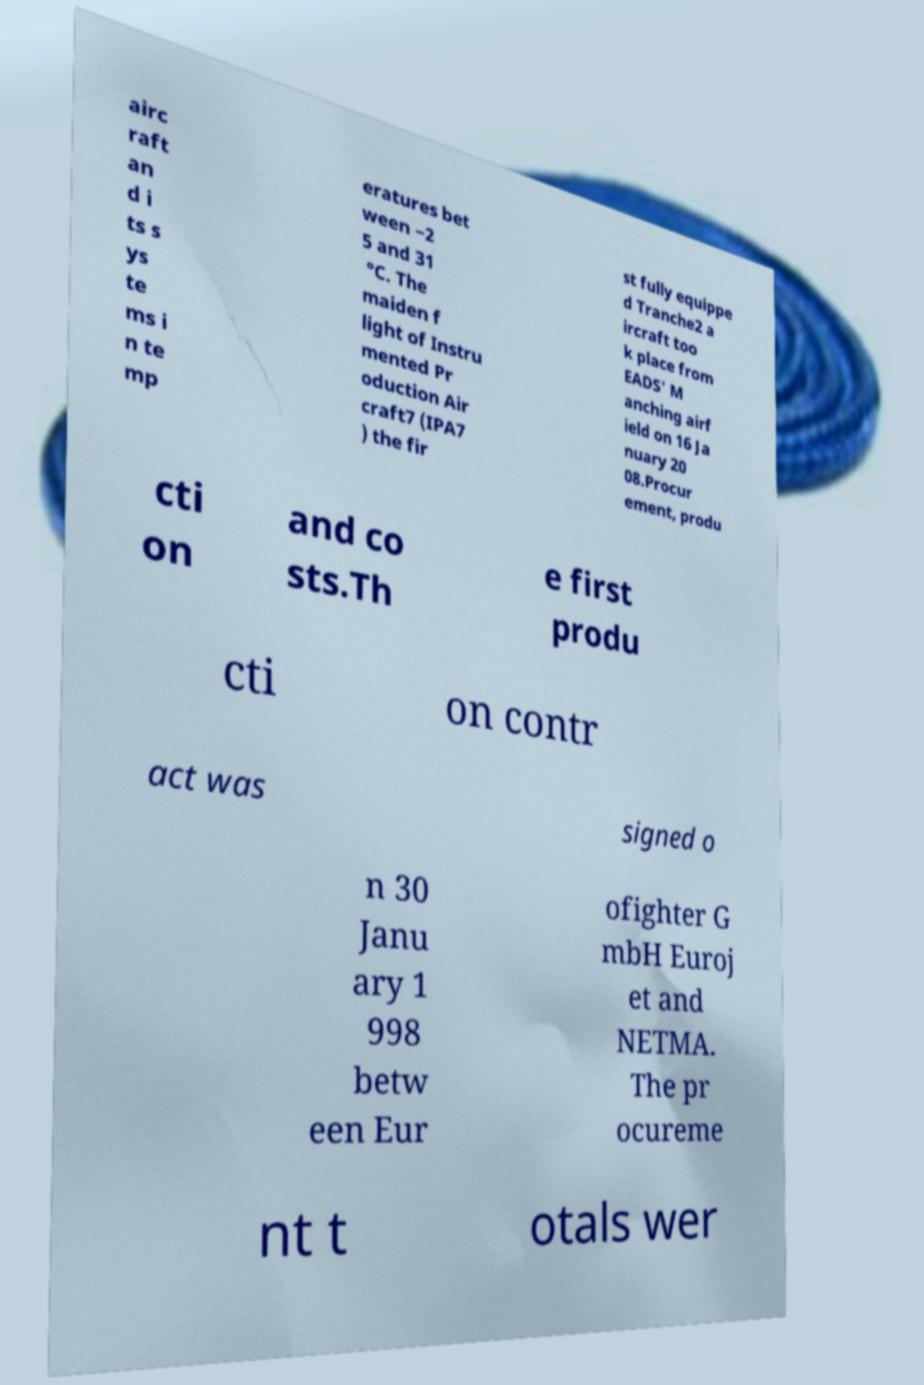Could you extract and type out the text from this image? airc raft an d i ts s ys te ms i n te mp eratures bet ween −2 5 and 31 °C. The maiden f light of Instru mented Pr oduction Air craft7 (IPA7 ) the fir st fully equippe d Tranche2 a ircraft too k place from EADS' M anching airf ield on 16 Ja nuary 20 08.Procur ement, produ cti on and co sts.Th e first produ cti on contr act was signed o n 30 Janu ary 1 998 betw een Eur ofighter G mbH Euroj et and NETMA. The pr ocureme nt t otals wer 